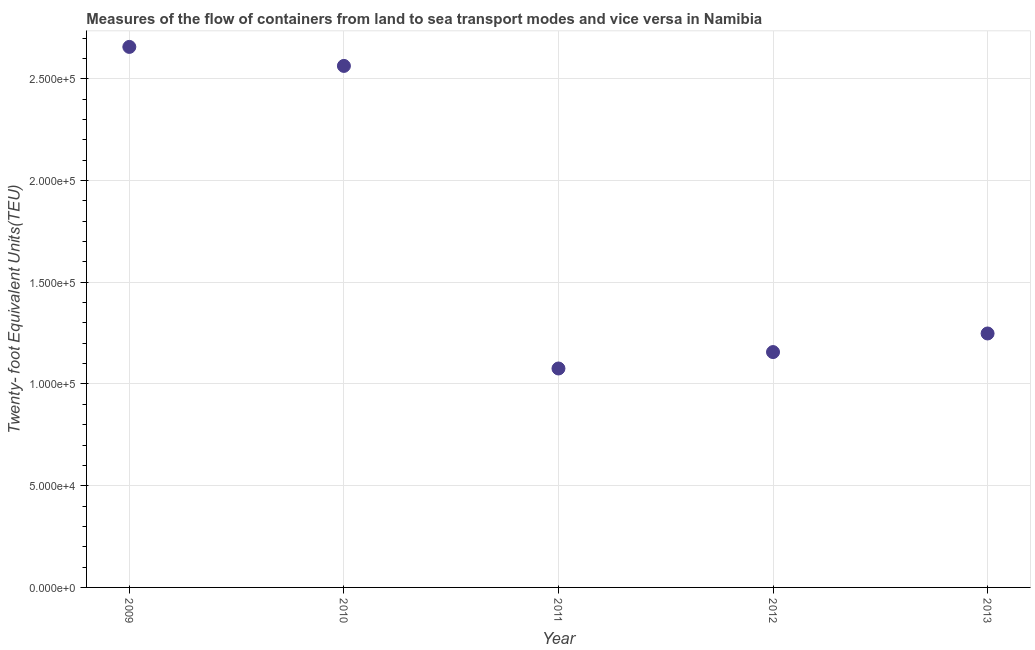What is the container port traffic in 2010?
Your answer should be very brief. 2.56e+05. Across all years, what is the maximum container port traffic?
Keep it short and to the point. 2.66e+05. Across all years, what is the minimum container port traffic?
Your answer should be compact. 1.08e+05. What is the sum of the container port traffic?
Keep it short and to the point. 8.70e+05. What is the difference between the container port traffic in 2012 and 2013?
Offer a terse response. -9138.44. What is the average container port traffic per year?
Provide a short and direct response. 1.74e+05. What is the median container port traffic?
Keep it short and to the point. 1.25e+05. In how many years, is the container port traffic greater than 20000 TEU?
Offer a very short reply. 5. Do a majority of the years between 2011 and 2010 (inclusive) have container port traffic greater than 70000 TEU?
Make the answer very short. No. What is the ratio of the container port traffic in 2010 to that in 2011?
Your answer should be very brief. 2.38. Is the container port traffic in 2011 less than that in 2013?
Your answer should be compact. Yes. Is the difference between the container port traffic in 2010 and 2011 greater than the difference between any two years?
Provide a short and direct response. No. What is the difference between the highest and the second highest container port traffic?
Make the answer very short. 9344. What is the difference between the highest and the lowest container port traffic?
Provide a short and direct response. 1.58e+05. In how many years, is the container port traffic greater than the average container port traffic taken over all years?
Ensure brevity in your answer.  2. How many dotlines are there?
Your response must be concise. 1. How many years are there in the graph?
Your answer should be compact. 5. What is the title of the graph?
Keep it short and to the point. Measures of the flow of containers from land to sea transport modes and vice versa in Namibia. What is the label or title of the Y-axis?
Your answer should be very brief. Twenty- foot Equivalent Units(TEU). What is the Twenty- foot Equivalent Units(TEU) in 2009?
Your answer should be very brief. 2.66e+05. What is the Twenty- foot Equivalent Units(TEU) in 2010?
Ensure brevity in your answer.  2.56e+05. What is the Twenty- foot Equivalent Units(TEU) in 2011?
Keep it short and to the point. 1.08e+05. What is the Twenty- foot Equivalent Units(TEU) in 2012?
Your response must be concise. 1.16e+05. What is the Twenty- foot Equivalent Units(TEU) in 2013?
Your response must be concise. 1.25e+05. What is the difference between the Twenty- foot Equivalent Units(TEU) in 2009 and 2010?
Offer a very short reply. 9344. What is the difference between the Twenty- foot Equivalent Units(TEU) in 2009 and 2011?
Offer a terse response. 1.58e+05. What is the difference between the Twenty- foot Equivalent Units(TEU) in 2009 and 2012?
Ensure brevity in your answer.  1.50e+05. What is the difference between the Twenty- foot Equivalent Units(TEU) in 2009 and 2013?
Provide a succinct answer. 1.41e+05. What is the difference between the Twenty- foot Equivalent Units(TEU) in 2010 and 2011?
Offer a very short reply. 1.49e+05. What is the difference between the Twenty- foot Equivalent Units(TEU) in 2010 and 2012?
Ensure brevity in your answer.  1.41e+05. What is the difference between the Twenty- foot Equivalent Units(TEU) in 2010 and 2013?
Offer a very short reply. 1.32e+05. What is the difference between the Twenty- foot Equivalent Units(TEU) in 2011 and 2012?
Offer a very short reply. -8070.45. What is the difference between the Twenty- foot Equivalent Units(TEU) in 2011 and 2013?
Your answer should be very brief. -1.72e+04. What is the difference between the Twenty- foot Equivalent Units(TEU) in 2012 and 2013?
Your answer should be very brief. -9138.44. What is the ratio of the Twenty- foot Equivalent Units(TEU) in 2009 to that in 2010?
Your answer should be very brief. 1.04. What is the ratio of the Twenty- foot Equivalent Units(TEU) in 2009 to that in 2011?
Provide a succinct answer. 2.47. What is the ratio of the Twenty- foot Equivalent Units(TEU) in 2009 to that in 2012?
Keep it short and to the point. 2.3. What is the ratio of the Twenty- foot Equivalent Units(TEU) in 2009 to that in 2013?
Give a very brief answer. 2.13. What is the ratio of the Twenty- foot Equivalent Units(TEU) in 2010 to that in 2011?
Keep it short and to the point. 2.38. What is the ratio of the Twenty- foot Equivalent Units(TEU) in 2010 to that in 2012?
Provide a succinct answer. 2.22. What is the ratio of the Twenty- foot Equivalent Units(TEU) in 2010 to that in 2013?
Provide a succinct answer. 2.05. What is the ratio of the Twenty- foot Equivalent Units(TEU) in 2011 to that in 2012?
Your answer should be compact. 0.93. What is the ratio of the Twenty- foot Equivalent Units(TEU) in 2011 to that in 2013?
Keep it short and to the point. 0.86. What is the ratio of the Twenty- foot Equivalent Units(TEU) in 2012 to that in 2013?
Your response must be concise. 0.93. 